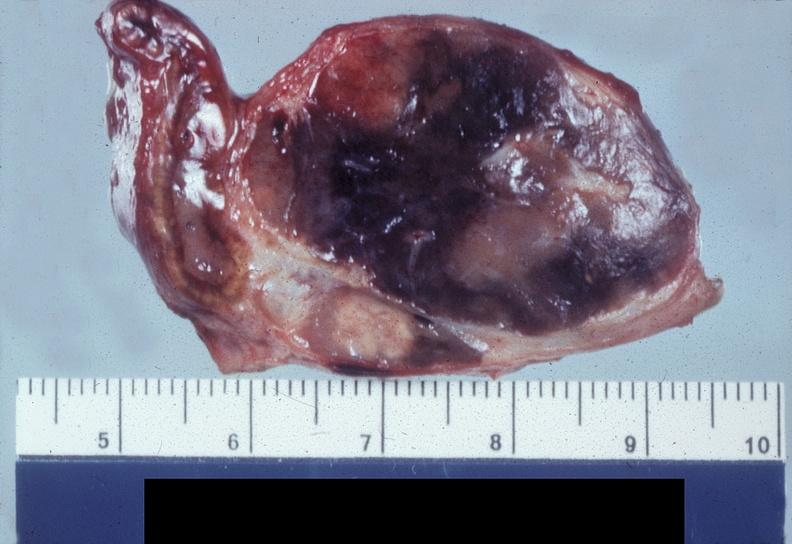what is present?
Answer the question using a single word or phrase. Endocrine 